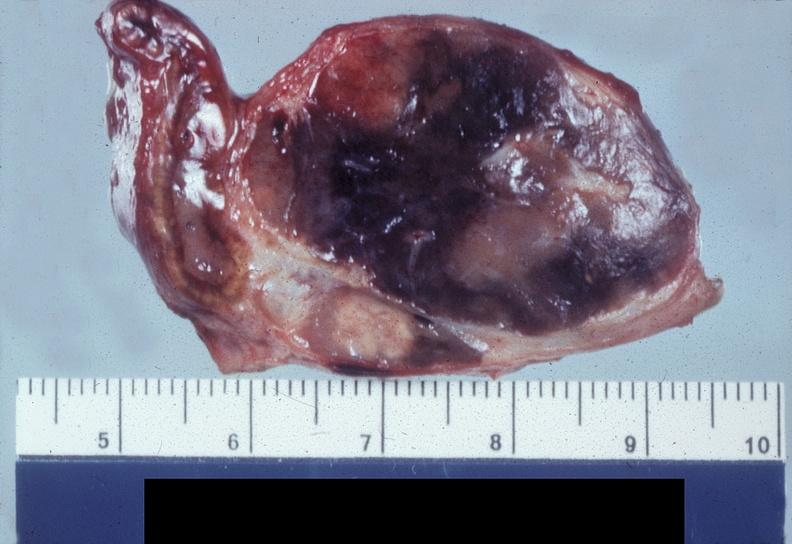what is present?
Answer the question using a single word or phrase. Endocrine 